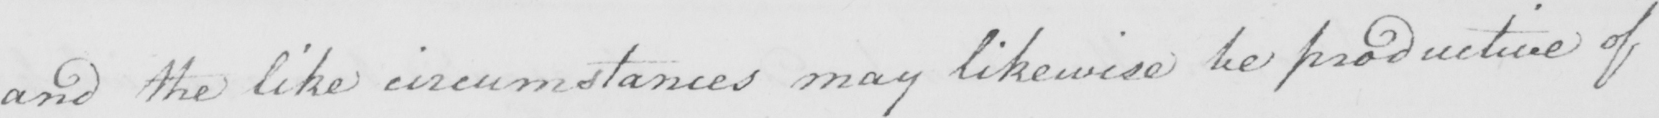Please provide the text content of this handwritten line. and the like circumstances may likewise be productive of 